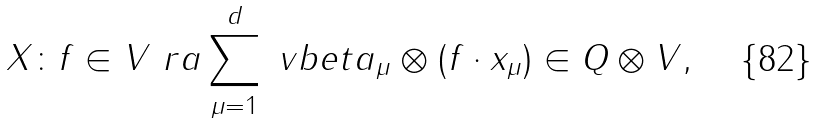<formula> <loc_0><loc_0><loc_500><loc_500>X \colon f \in V \ r a \sum _ { \mu = 1 } ^ { d } \ v b e t a _ { \mu } \otimes ( f \cdot x _ { \mu } ) \in Q \otimes V ,</formula> 